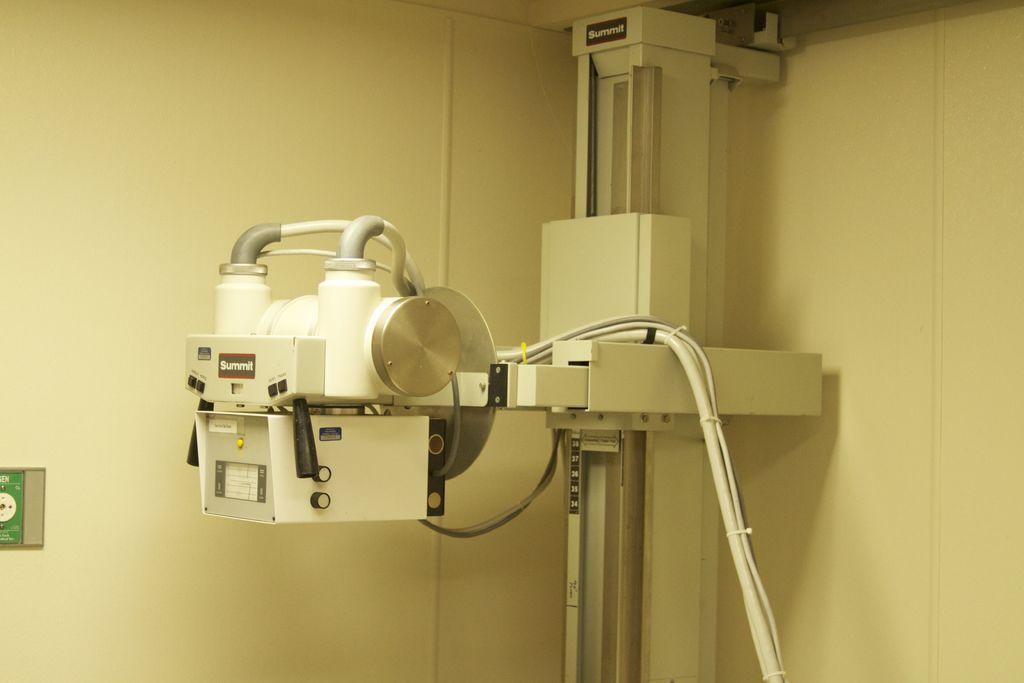Please provide a concise description of this image. This is the picture of a room. In this image there is an object and there are wires. On the left side of the image there is an object on the wall and there is text on the object. 